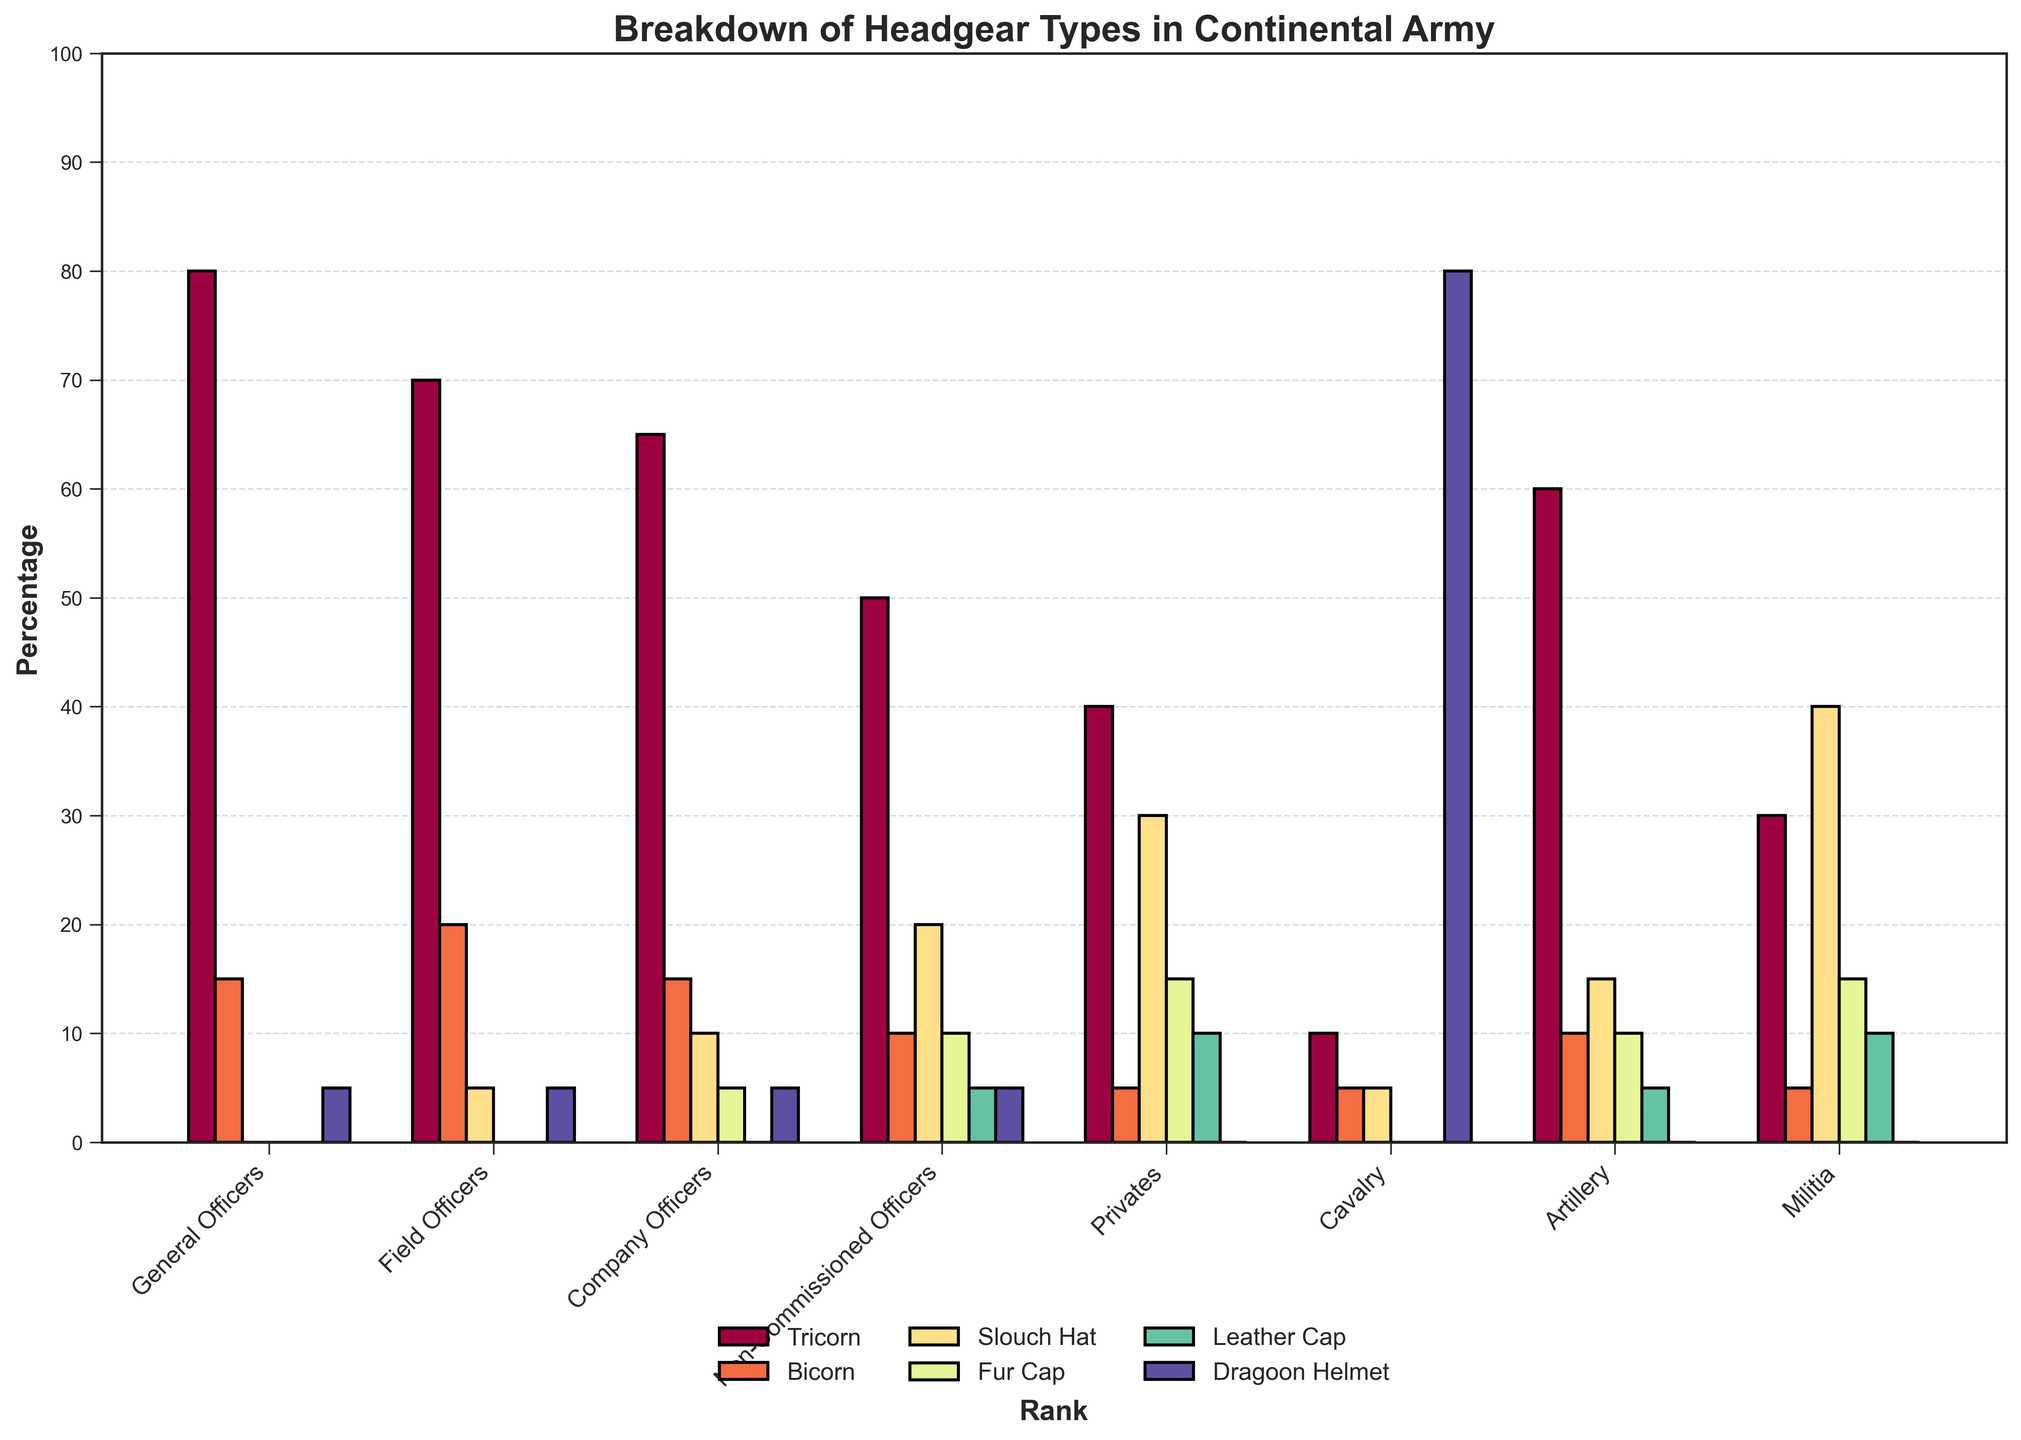Which rank has the highest percentage of soldiers wearing Dragoon Helmets? Check the data for the percentage of Dragoon Helmets for each rank. The Cavalry rank has the highest percentage with 80%.
Answer: Cavalry What percentage of Militia wear Tricorn hats compared to Field Officers? Compare the percentage listed for Militia and Field Officers under the Tricorn column. Militia is at 30%, and Field Officers are at 70%.
Answer: 30% vs 70% For the rank of Artillery, what is the combined percentage of soldiers wearing Fur Caps and Leather Caps? Add the percentages in the Fur Cap and Leather Cap columns for the Artillery rank. This is 10% + 5%.
Answer: 15% Which headgear is worn by the highest percentage of General Officers? Look for the highest percentage in the row for General Officers. The Tricorn hat is worn by 80%.
Answer: Tricorn How does the percentage of Privates wearing Slouch Hats compare to the percentage of Company Officers wearing the same? Compare the percentages in the Slouch Hat column for Privates and Company Officers. Privates have 30%, and Company Officers have 10%.
Answer: 30% vs 10% What is the difference in percentage between Non-Commissioned Officers and Company Officers wearing Leather Caps? Subtract the percentage of Company Officers wearing Leather Caps from Non-Commissioned Officers. This is 5% - 0%.
Answer: 5% For the rank Cavalry, what is the ratio of soldiers wearing Dragoon Helmets to those wearing Tricorn hats? For Cavalry, the percentage for Dragoon Helmets is 80%, and for Tricorn hats, it's 10%. The ratio is 80:10, which simplifies to 8:1.
Answer: 8:1 Among Privates, what is the percentage point difference between those wearing Fur Caps and those wearing Slouch Hats? Subtract the percentage of those wearing Fur Caps from those wearing Slouch Hats among Privates. This is 30% - 15%.
Answer: 15% Which rank has the largest variety of headgear worn equally (measured by having no zero values across all headgear types)? Scan the data for the rank which has non-zero values for all columns. Company Officers, Non-Commissioned Officers, and Artillery fit, but Non-Commissioned Officers have more variety.
Answer: Non-Commissioned Officers 